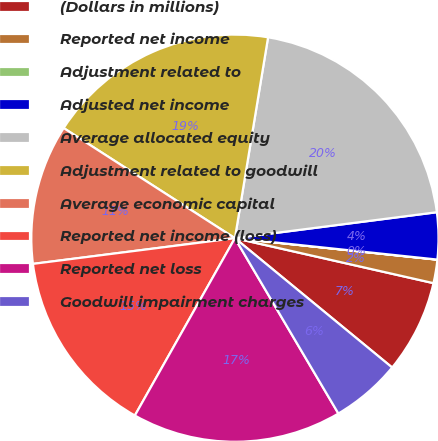Convert chart to OTSL. <chart><loc_0><loc_0><loc_500><loc_500><pie_chart><fcel>(Dollars in millions)<fcel>Reported net income<fcel>Adjustment related to<fcel>Adjusted net income<fcel>Average allocated equity<fcel>Adjustment related to goodwill<fcel>Average economic capital<fcel>Reported net income (loss)<fcel>Reported net loss<fcel>Goodwill impairment charges<nl><fcel>7.41%<fcel>1.86%<fcel>0.01%<fcel>3.71%<fcel>20.36%<fcel>18.51%<fcel>11.11%<fcel>14.81%<fcel>16.66%<fcel>5.56%<nl></chart> 